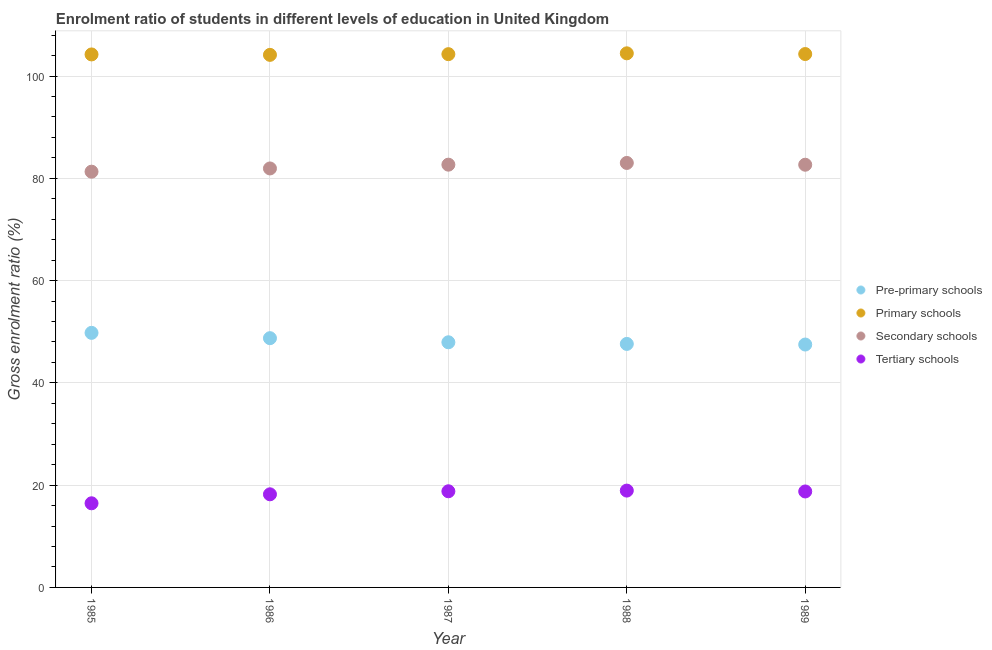How many different coloured dotlines are there?
Your answer should be compact. 4. What is the gross enrolment ratio in pre-primary schools in 1987?
Offer a very short reply. 47.93. Across all years, what is the maximum gross enrolment ratio in pre-primary schools?
Ensure brevity in your answer.  49.78. Across all years, what is the minimum gross enrolment ratio in primary schools?
Keep it short and to the point. 104.13. In which year was the gross enrolment ratio in secondary schools maximum?
Your answer should be compact. 1988. In which year was the gross enrolment ratio in primary schools minimum?
Make the answer very short. 1986. What is the total gross enrolment ratio in pre-primary schools in the graph?
Offer a very short reply. 241.56. What is the difference between the gross enrolment ratio in secondary schools in 1986 and that in 1988?
Make the answer very short. -1.08. What is the difference between the gross enrolment ratio in secondary schools in 1989 and the gross enrolment ratio in tertiary schools in 1988?
Ensure brevity in your answer.  63.72. What is the average gross enrolment ratio in tertiary schools per year?
Your response must be concise. 18.23. In the year 1986, what is the difference between the gross enrolment ratio in primary schools and gross enrolment ratio in tertiary schools?
Ensure brevity in your answer.  85.93. In how many years, is the gross enrolment ratio in tertiary schools greater than 88 %?
Provide a short and direct response. 0. What is the ratio of the gross enrolment ratio in tertiary schools in 1985 to that in 1986?
Offer a very short reply. 0.9. Is the gross enrolment ratio in pre-primary schools in 1985 less than that in 1986?
Offer a terse response. No. Is the difference between the gross enrolment ratio in tertiary schools in 1987 and 1988 greater than the difference between the gross enrolment ratio in pre-primary schools in 1987 and 1988?
Keep it short and to the point. No. What is the difference between the highest and the second highest gross enrolment ratio in secondary schools?
Offer a very short reply. 0.34. What is the difference between the highest and the lowest gross enrolment ratio in secondary schools?
Offer a very short reply. 1.71. In how many years, is the gross enrolment ratio in pre-primary schools greater than the average gross enrolment ratio in pre-primary schools taken over all years?
Ensure brevity in your answer.  2. Is it the case that in every year, the sum of the gross enrolment ratio in secondary schools and gross enrolment ratio in tertiary schools is greater than the sum of gross enrolment ratio in primary schools and gross enrolment ratio in pre-primary schools?
Your answer should be very brief. Yes. Does the gross enrolment ratio in tertiary schools monotonically increase over the years?
Your response must be concise. No. Is the gross enrolment ratio in pre-primary schools strictly less than the gross enrolment ratio in secondary schools over the years?
Keep it short and to the point. Yes. How many dotlines are there?
Offer a terse response. 4. How many years are there in the graph?
Give a very brief answer. 5. Are the values on the major ticks of Y-axis written in scientific E-notation?
Your answer should be compact. No. Does the graph contain grids?
Ensure brevity in your answer.  Yes. Where does the legend appear in the graph?
Make the answer very short. Center right. How many legend labels are there?
Keep it short and to the point. 4. How are the legend labels stacked?
Offer a terse response. Vertical. What is the title of the graph?
Your answer should be compact. Enrolment ratio of students in different levels of education in United Kingdom. What is the label or title of the Y-axis?
Offer a terse response. Gross enrolment ratio (%). What is the Gross enrolment ratio (%) of Pre-primary schools in 1985?
Provide a short and direct response. 49.78. What is the Gross enrolment ratio (%) of Primary schools in 1985?
Keep it short and to the point. 104.22. What is the Gross enrolment ratio (%) in Secondary schools in 1985?
Keep it short and to the point. 81.29. What is the Gross enrolment ratio (%) of Tertiary schools in 1985?
Your response must be concise. 16.45. What is the Gross enrolment ratio (%) in Pre-primary schools in 1986?
Keep it short and to the point. 48.74. What is the Gross enrolment ratio (%) of Primary schools in 1986?
Provide a succinct answer. 104.13. What is the Gross enrolment ratio (%) in Secondary schools in 1986?
Your answer should be very brief. 81.92. What is the Gross enrolment ratio (%) in Tertiary schools in 1986?
Provide a succinct answer. 18.21. What is the Gross enrolment ratio (%) in Pre-primary schools in 1987?
Give a very brief answer. 47.93. What is the Gross enrolment ratio (%) of Primary schools in 1987?
Provide a succinct answer. 104.27. What is the Gross enrolment ratio (%) of Secondary schools in 1987?
Ensure brevity in your answer.  82.66. What is the Gross enrolment ratio (%) in Tertiary schools in 1987?
Your response must be concise. 18.8. What is the Gross enrolment ratio (%) in Pre-primary schools in 1988?
Provide a succinct answer. 47.61. What is the Gross enrolment ratio (%) in Primary schools in 1988?
Provide a succinct answer. 104.44. What is the Gross enrolment ratio (%) in Secondary schools in 1988?
Your answer should be very brief. 83. What is the Gross enrolment ratio (%) in Tertiary schools in 1988?
Offer a terse response. 18.93. What is the Gross enrolment ratio (%) in Pre-primary schools in 1989?
Offer a very short reply. 47.49. What is the Gross enrolment ratio (%) of Primary schools in 1989?
Make the answer very short. 104.29. What is the Gross enrolment ratio (%) of Secondary schools in 1989?
Your answer should be very brief. 82.65. What is the Gross enrolment ratio (%) in Tertiary schools in 1989?
Provide a succinct answer. 18.76. Across all years, what is the maximum Gross enrolment ratio (%) of Pre-primary schools?
Your answer should be very brief. 49.78. Across all years, what is the maximum Gross enrolment ratio (%) of Primary schools?
Give a very brief answer. 104.44. Across all years, what is the maximum Gross enrolment ratio (%) in Secondary schools?
Provide a succinct answer. 83. Across all years, what is the maximum Gross enrolment ratio (%) in Tertiary schools?
Keep it short and to the point. 18.93. Across all years, what is the minimum Gross enrolment ratio (%) of Pre-primary schools?
Give a very brief answer. 47.49. Across all years, what is the minimum Gross enrolment ratio (%) in Primary schools?
Your answer should be very brief. 104.13. Across all years, what is the minimum Gross enrolment ratio (%) of Secondary schools?
Make the answer very short. 81.29. Across all years, what is the minimum Gross enrolment ratio (%) of Tertiary schools?
Offer a terse response. 16.45. What is the total Gross enrolment ratio (%) of Pre-primary schools in the graph?
Provide a short and direct response. 241.56. What is the total Gross enrolment ratio (%) in Primary schools in the graph?
Your answer should be very brief. 521.36. What is the total Gross enrolment ratio (%) of Secondary schools in the graph?
Your response must be concise. 411.53. What is the total Gross enrolment ratio (%) of Tertiary schools in the graph?
Offer a terse response. 91.16. What is the difference between the Gross enrolment ratio (%) of Pre-primary schools in 1985 and that in 1986?
Your response must be concise. 1.04. What is the difference between the Gross enrolment ratio (%) in Primary schools in 1985 and that in 1986?
Offer a terse response. 0.08. What is the difference between the Gross enrolment ratio (%) of Secondary schools in 1985 and that in 1986?
Your response must be concise. -0.63. What is the difference between the Gross enrolment ratio (%) in Tertiary schools in 1985 and that in 1986?
Your answer should be compact. -1.76. What is the difference between the Gross enrolment ratio (%) in Pre-primary schools in 1985 and that in 1987?
Keep it short and to the point. 1.84. What is the difference between the Gross enrolment ratio (%) of Primary schools in 1985 and that in 1987?
Keep it short and to the point. -0.05. What is the difference between the Gross enrolment ratio (%) of Secondary schools in 1985 and that in 1987?
Keep it short and to the point. -1.37. What is the difference between the Gross enrolment ratio (%) of Tertiary schools in 1985 and that in 1987?
Ensure brevity in your answer.  -2.35. What is the difference between the Gross enrolment ratio (%) of Pre-primary schools in 1985 and that in 1988?
Give a very brief answer. 2.16. What is the difference between the Gross enrolment ratio (%) of Primary schools in 1985 and that in 1988?
Make the answer very short. -0.22. What is the difference between the Gross enrolment ratio (%) in Secondary schools in 1985 and that in 1988?
Your response must be concise. -1.71. What is the difference between the Gross enrolment ratio (%) of Tertiary schools in 1985 and that in 1988?
Your response must be concise. -2.48. What is the difference between the Gross enrolment ratio (%) of Pre-primary schools in 1985 and that in 1989?
Provide a short and direct response. 2.28. What is the difference between the Gross enrolment ratio (%) of Primary schools in 1985 and that in 1989?
Offer a very short reply. -0.08. What is the difference between the Gross enrolment ratio (%) in Secondary schools in 1985 and that in 1989?
Offer a terse response. -1.36. What is the difference between the Gross enrolment ratio (%) in Tertiary schools in 1985 and that in 1989?
Offer a terse response. -2.31. What is the difference between the Gross enrolment ratio (%) in Pre-primary schools in 1986 and that in 1987?
Your response must be concise. 0.8. What is the difference between the Gross enrolment ratio (%) in Primary schools in 1986 and that in 1987?
Provide a succinct answer. -0.14. What is the difference between the Gross enrolment ratio (%) of Secondary schools in 1986 and that in 1987?
Your answer should be very brief. -0.74. What is the difference between the Gross enrolment ratio (%) of Tertiary schools in 1986 and that in 1987?
Ensure brevity in your answer.  -0.59. What is the difference between the Gross enrolment ratio (%) of Pre-primary schools in 1986 and that in 1988?
Give a very brief answer. 1.12. What is the difference between the Gross enrolment ratio (%) in Primary schools in 1986 and that in 1988?
Keep it short and to the point. -0.3. What is the difference between the Gross enrolment ratio (%) of Secondary schools in 1986 and that in 1988?
Provide a short and direct response. -1.08. What is the difference between the Gross enrolment ratio (%) in Tertiary schools in 1986 and that in 1988?
Provide a succinct answer. -0.73. What is the difference between the Gross enrolment ratio (%) in Pre-primary schools in 1986 and that in 1989?
Your answer should be compact. 1.24. What is the difference between the Gross enrolment ratio (%) in Primary schools in 1986 and that in 1989?
Your response must be concise. -0.16. What is the difference between the Gross enrolment ratio (%) of Secondary schools in 1986 and that in 1989?
Offer a very short reply. -0.73. What is the difference between the Gross enrolment ratio (%) in Tertiary schools in 1986 and that in 1989?
Offer a very short reply. -0.56. What is the difference between the Gross enrolment ratio (%) in Pre-primary schools in 1987 and that in 1988?
Offer a terse response. 0.32. What is the difference between the Gross enrolment ratio (%) in Primary schools in 1987 and that in 1988?
Ensure brevity in your answer.  -0.16. What is the difference between the Gross enrolment ratio (%) in Secondary schools in 1987 and that in 1988?
Offer a terse response. -0.34. What is the difference between the Gross enrolment ratio (%) in Tertiary schools in 1987 and that in 1988?
Your answer should be compact. -0.13. What is the difference between the Gross enrolment ratio (%) in Pre-primary schools in 1987 and that in 1989?
Make the answer very short. 0.44. What is the difference between the Gross enrolment ratio (%) in Primary schools in 1987 and that in 1989?
Offer a very short reply. -0.02. What is the difference between the Gross enrolment ratio (%) of Secondary schools in 1987 and that in 1989?
Your response must be concise. 0.01. What is the difference between the Gross enrolment ratio (%) of Tertiary schools in 1987 and that in 1989?
Give a very brief answer. 0.04. What is the difference between the Gross enrolment ratio (%) in Pre-primary schools in 1988 and that in 1989?
Give a very brief answer. 0.12. What is the difference between the Gross enrolment ratio (%) of Primary schools in 1988 and that in 1989?
Provide a short and direct response. 0.14. What is the difference between the Gross enrolment ratio (%) in Secondary schools in 1988 and that in 1989?
Your answer should be compact. 0.35. What is the difference between the Gross enrolment ratio (%) of Tertiary schools in 1988 and that in 1989?
Make the answer very short. 0.17. What is the difference between the Gross enrolment ratio (%) in Pre-primary schools in 1985 and the Gross enrolment ratio (%) in Primary schools in 1986?
Give a very brief answer. -54.36. What is the difference between the Gross enrolment ratio (%) in Pre-primary schools in 1985 and the Gross enrolment ratio (%) in Secondary schools in 1986?
Your response must be concise. -32.15. What is the difference between the Gross enrolment ratio (%) of Pre-primary schools in 1985 and the Gross enrolment ratio (%) of Tertiary schools in 1986?
Provide a succinct answer. 31.57. What is the difference between the Gross enrolment ratio (%) of Primary schools in 1985 and the Gross enrolment ratio (%) of Secondary schools in 1986?
Offer a very short reply. 22.29. What is the difference between the Gross enrolment ratio (%) of Primary schools in 1985 and the Gross enrolment ratio (%) of Tertiary schools in 1986?
Provide a succinct answer. 86.01. What is the difference between the Gross enrolment ratio (%) in Secondary schools in 1985 and the Gross enrolment ratio (%) in Tertiary schools in 1986?
Provide a short and direct response. 63.08. What is the difference between the Gross enrolment ratio (%) of Pre-primary schools in 1985 and the Gross enrolment ratio (%) of Primary schools in 1987?
Make the answer very short. -54.5. What is the difference between the Gross enrolment ratio (%) of Pre-primary schools in 1985 and the Gross enrolment ratio (%) of Secondary schools in 1987?
Keep it short and to the point. -32.89. What is the difference between the Gross enrolment ratio (%) of Pre-primary schools in 1985 and the Gross enrolment ratio (%) of Tertiary schools in 1987?
Keep it short and to the point. 30.97. What is the difference between the Gross enrolment ratio (%) of Primary schools in 1985 and the Gross enrolment ratio (%) of Secondary schools in 1987?
Give a very brief answer. 21.55. What is the difference between the Gross enrolment ratio (%) of Primary schools in 1985 and the Gross enrolment ratio (%) of Tertiary schools in 1987?
Offer a terse response. 85.42. What is the difference between the Gross enrolment ratio (%) in Secondary schools in 1985 and the Gross enrolment ratio (%) in Tertiary schools in 1987?
Keep it short and to the point. 62.49. What is the difference between the Gross enrolment ratio (%) of Pre-primary schools in 1985 and the Gross enrolment ratio (%) of Primary schools in 1988?
Your answer should be compact. -54.66. What is the difference between the Gross enrolment ratio (%) in Pre-primary schools in 1985 and the Gross enrolment ratio (%) in Secondary schools in 1988?
Give a very brief answer. -33.23. What is the difference between the Gross enrolment ratio (%) in Pre-primary schools in 1985 and the Gross enrolment ratio (%) in Tertiary schools in 1988?
Offer a very short reply. 30.84. What is the difference between the Gross enrolment ratio (%) in Primary schools in 1985 and the Gross enrolment ratio (%) in Secondary schools in 1988?
Provide a succinct answer. 21.22. What is the difference between the Gross enrolment ratio (%) in Primary schools in 1985 and the Gross enrolment ratio (%) in Tertiary schools in 1988?
Your answer should be compact. 85.28. What is the difference between the Gross enrolment ratio (%) in Secondary schools in 1985 and the Gross enrolment ratio (%) in Tertiary schools in 1988?
Ensure brevity in your answer.  62.36. What is the difference between the Gross enrolment ratio (%) of Pre-primary schools in 1985 and the Gross enrolment ratio (%) of Primary schools in 1989?
Give a very brief answer. -54.52. What is the difference between the Gross enrolment ratio (%) in Pre-primary schools in 1985 and the Gross enrolment ratio (%) in Secondary schools in 1989?
Your answer should be very brief. -32.88. What is the difference between the Gross enrolment ratio (%) in Pre-primary schools in 1985 and the Gross enrolment ratio (%) in Tertiary schools in 1989?
Provide a short and direct response. 31.01. What is the difference between the Gross enrolment ratio (%) of Primary schools in 1985 and the Gross enrolment ratio (%) of Secondary schools in 1989?
Your answer should be compact. 21.57. What is the difference between the Gross enrolment ratio (%) of Primary schools in 1985 and the Gross enrolment ratio (%) of Tertiary schools in 1989?
Give a very brief answer. 85.45. What is the difference between the Gross enrolment ratio (%) of Secondary schools in 1985 and the Gross enrolment ratio (%) of Tertiary schools in 1989?
Make the answer very short. 62.53. What is the difference between the Gross enrolment ratio (%) in Pre-primary schools in 1986 and the Gross enrolment ratio (%) in Primary schools in 1987?
Your answer should be very brief. -55.53. What is the difference between the Gross enrolment ratio (%) of Pre-primary schools in 1986 and the Gross enrolment ratio (%) of Secondary schools in 1987?
Provide a succinct answer. -33.93. What is the difference between the Gross enrolment ratio (%) in Pre-primary schools in 1986 and the Gross enrolment ratio (%) in Tertiary schools in 1987?
Ensure brevity in your answer.  29.94. What is the difference between the Gross enrolment ratio (%) of Primary schools in 1986 and the Gross enrolment ratio (%) of Secondary schools in 1987?
Provide a succinct answer. 21.47. What is the difference between the Gross enrolment ratio (%) of Primary schools in 1986 and the Gross enrolment ratio (%) of Tertiary schools in 1987?
Offer a terse response. 85.33. What is the difference between the Gross enrolment ratio (%) in Secondary schools in 1986 and the Gross enrolment ratio (%) in Tertiary schools in 1987?
Provide a short and direct response. 63.12. What is the difference between the Gross enrolment ratio (%) in Pre-primary schools in 1986 and the Gross enrolment ratio (%) in Primary schools in 1988?
Make the answer very short. -55.7. What is the difference between the Gross enrolment ratio (%) of Pre-primary schools in 1986 and the Gross enrolment ratio (%) of Secondary schools in 1988?
Make the answer very short. -34.26. What is the difference between the Gross enrolment ratio (%) of Pre-primary schools in 1986 and the Gross enrolment ratio (%) of Tertiary schools in 1988?
Your answer should be compact. 29.8. What is the difference between the Gross enrolment ratio (%) in Primary schools in 1986 and the Gross enrolment ratio (%) in Secondary schools in 1988?
Provide a short and direct response. 21.13. What is the difference between the Gross enrolment ratio (%) of Primary schools in 1986 and the Gross enrolment ratio (%) of Tertiary schools in 1988?
Ensure brevity in your answer.  85.2. What is the difference between the Gross enrolment ratio (%) of Secondary schools in 1986 and the Gross enrolment ratio (%) of Tertiary schools in 1988?
Your answer should be very brief. 62.99. What is the difference between the Gross enrolment ratio (%) of Pre-primary schools in 1986 and the Gross enrolment ratio (%) of Primary schools in 1989?
Offer a terse response. -55.56. What is the difference between the Gross enrolment ratio (%) in Pre-primary schools in 1986 and the Gross enrolment ratio (%) in Secondary schools in 1989?
Provide a short and direct response. -33.91. What is the difference between the Gross enrolment ratio (%) of Pre-primary schools in 1986 and the Gross enrolment ratio (%) of Tertiary schools in 1989?
Offer a terse response. 29.97. What is the difference between the Gross enrolment ratio (%) of Primary schools in 1986 and the Gross enrolment ratio (%) of Secondary schools in 1989?
Your answer should be compact. 21.48. What is the difference between the Gross enrolment ratio (%) of Primary schools in 1986 and the Gross enrolment ratio (%) of Tertiary schools in 1989?
Your answer should be compact. 85.37. What is the difference between the Gross enrolment ratio (%) of Secondary schools in 1986 and the Gross enrolment ratio (%) of Tertiary schools in 1989?
Your answer should be compact. 63.16. What is the difference between the Gross enrolment ratio (%) in Pre-primary schools in 1987 and the Gross enrolment ratio (%) in Primary schools in 1988?
Your response must be concise. -56.5. What is the difference between the Gross enrolment ratio (%) in Pre-primary schools in 1987 and the Gross enrolment ratio (%) in Secondary schools in 1988?
Give a very brief answer. -35.07. What is the difference between the Gross enrolment ratio (%) of Pre-primary schools in 1987 and the Gross enrolment ratio (%) of Tertiary schools in 1988?
Provide a short and direct response. 29. What is the difference between the Gross enrolment ratio (%) in Primary schools in 1987 and the Gross enrolment ratio (%) in Secondary schools in 1988?
Provide a short and direct response. 21.27. What is the difference between the Gross enrolment ratio (%) in Primary schools in 1987 and the Gross enrolment ratio (%) in Tertiary schools in 1988?
Make the answer very short. 85.34. What is the difference between the Gross enrolment ratio (%) in Secondary schools in 1987 and the Gross enrolment ratio (%) in Tertiary schools in 1988?
Offer a terse response. 63.73. What is the difference between the Gross enrolment ratio (%) in Pre-primary schools in 1987 and the Gross enrolment ratio (%) in Primary schools in 1989?
Offer a terse response. -56.36. What is the difference between the Gross enrolment ratio (%) in Pre-primary schools in 1987 and the Gross enrolment ratio (%) in Secondary schools in 1989?
Your answer should be compact. -34.72. What is the difference between the Gross enrolment ratio (%) in Pre-primary schools in 1987 and the Gross enrolment ratio (%) in Tertiary schools in 1989?
Keep it short and to the point. 29.17. What is the difference between the Gross enrolment ratio (%) of Primary schools in 1987 and the Gross enrolment ratio (%) of Secondary schools in 1989?
Your response must be concise. 21.62. What is the difference between the Gross enrolment ratio (%) of Primary schools in 1987 and the Gross enrolment ratio (%) of Tertiary schools in 1989?
Give a very brief answer. 85.51. What is the difference between the Gross enrolment ratio (%) in Secondary schools in 1987 and the Gross enrolment ratio (%) in Tertiary schools in 1989?
Provide a short and direct response. 63.9. What is the difference between the Gross enrolment ratio (%) in Pre-primary schools in 1988 and the Gross enrolment ratio (%) in Primary schools in 1989?
Offer a very short reply. -56.68. What is the difference between the Gross enrolment ratio (%) of Pre-primary schools in 1988 and the Gross enrolment ratio (%) of Secondary schools in 1989?
Make the answer very short. -35.04. What is the difference between the Gross enrolment ratio (%) of Pre-primary schools in 1988 and the Gross enrolment ratio (%) of Tertiary schools in 1989?
Offer a very short reply. 28.85. What is the difference between the Gross enrolment ratio (%) in Primary schools in 1988 and the Gross enrolment ratio (%) in Secondary schools in 1989?
Give a very brief answer. 21.78. What is the difference between the Gross enrolment ratio (%) in Primary schools in 1988 and the Gross enrolment ratio (%) in Tertiary schools in 1989?
Offer a very short reply. 85.67. What is the difference between the Gross enrolment ratio (%) in Secondary schools in 1988 and the Gross enrolment ratio (%) in Tertiary schools in 1989?
Provide a short and direct response. 64.24. What is the average Gross enrolment ratio (%) in Pre-primary schools per year?
Provide a short and direct response. 48.31. What is the average Gross enrolment ratio (%) in Primary schools per year?
Your response must be concise. 104.27. What is the average Gross enrolment ratio (%) of Secondary schools per year?
Provide a succinct answer. 82.31. What is the average Gross enrolment ratio (%) of Tertiary schools per year?
Make the answer very short. 18.23. In the year 1985, what is the difference between the Gross enrolment ratio (%) in Pre-primary schools and Gross enrolment ratio (%) in Primary schools?
Offer a very short reply. -54.44. In the year 1985, what is the difference between the Gross enrolment ratio (%) in Pre-primary schools and Gross enrolment ratio (%) in Secondary schools?
Your answer should be compact. -31.52. In the year 1985, what is the difference between the Gross enrolment ratio (%) of Pre-primary schools and Gross enrolment ratio (%) of Tertiary schools?
Your response must be concise. 33.32. In the year 1985, what is the difference between the Gross enrolment ratio (%) in Primary schools and Gross enrolment ratio (%) in Secondary schools?
Give a very brief answer. 22.93. In the year 1985, what is the difference between the Gross enrolment ratio (%) in Primary schools and Gross enrolment ratio (%) in Tertiary schools?
Offer a terse response. 87.77. In the year 1985, what is the difference between the Gross enrolment ratio (%) of Secondary schools and Gross enrolment ratio (%) of Tertiary schools?
Provide a short and direct response. 64.84. In the year 1986, what is the difference between the Gross enrolment ratio (%) of Pre-primary schools and Gross enrolment ratio (%) of Primary schools?
Your response must be concise. -55.4. In the year 1986, what is the difference between the Gross enrolment ratio (%) of Pre-primary schools and Gross enrolment ratio (%) of Secondary schools?
Keep it short and to the point. -33.19. In the year 1986, what is the difference between the Gross enrolment ratio (%) of Pre-primary schools and Gross enrolment ratio (%) of Tertiary schools?
Your response must be concise. 30.53. In the year 1986, what is the difference between the Gross enrolment ratio (%) in Primary schools and Gross enrolment ratio (%) in Secondary schools?
Keep it short and to the point. 22.21. In the year 1986, what is the difference between the Gross enrolment ratio (%) in Primary schools and Gross enrolment ratio (%) in Tertiary schools?
Make the answer very short. 85.93. In the year 1986, what is the difference between the Gross enrolment ratio (%) in Secondary schools and Gross enrolment ratio (%) in Tertiary schools?
Your answer should be compact. 63.72. In the year 1987, what is the difference between the Gross enrolment ratio (%) of Pre-primary schools and Gross enrolment ratio (%) of Primary schools?
Keep it short and to the point. -56.34. In the year 1987, what is the difference between the Gross enrolment ratio (%) in Pre-primary schools and Gross enrolment ratio (%) in Secondary schools?
Offer a terse response. -34.73. In the year 1987, what is the difference between the Gross enrolment ratio (%) of Pre-primary schools and Gross enrolment ratio (%) of Tertiary schools?
Your response must be concise. 29.13. In the year 1987, what is the difference between the Gross enrolment ratio (%) of Primary schools and Gross enrolment ratio (%) of Secondary schools?
Your response must be concise. 21.61. In the year 1987, what is the difference between the Gross enrolment ratio (%) of Primary schools and Gross enrolment ratio (%) of Tertiary schools?
Offer a terse response. 85.47. In the year 1987, what is the difference between the Gross enrolment ratio (%) of Secondary schools and Gross enrolment ratio (%) of Tertiary schools?
Provide a short and direct response. 63.86. In the year 1988, what is the difference between the Gross enrolment ratio (%) in Pre-primary schools and Gross enrolment ratio (%) in Primary schools?
Your response must be concise. -56.82. In the year 1988, what is the difference between the Gross enrolment ratio (%) of Pre-primary schools and Gross enrolment ratio (%) of Secondary schools?
Offer a terse response. -35.39. In the year 1988, what is the difference between the Gross enrolment ratio (%) in Pre-primary schools and Gross enrolment ratio (%) in Tertiary schools?
Ensure brevity in your answer.  28.68. In the year 1988, what is the difference between the Gross enrolment ratio (%) in Primary schools and Gross enrolment ratio (%) in Secondary schools?
Make the answer very short. 21.43. In the year 1988, what is the difference between the Gross enrolment ratio (%) of Primary schools and Gross enrolment ratio (%) of Tertiary schools?
Offer a very short reply. 85.5. In the year 1988, what is the difference between the Gross enrolment ratio (%) in Secondary schools and Gross enrolment ratio (%) in Tertiary schools?
Your answer should be compact. 64.07. In the year 1989, what is the difference between the Gross enrolment ratio (%) of Pre-primary schools and Gross enrolment ratio (%) of Primary schools?
Your response must be concise. -56.8. In the year 1989, what is the difference between the Gross enrolment ratio (%) of Pre-primary schools and Gross enrolment ratio (%) of Secondary schools?
Your answer should be very brief. -35.16. In the year 1989, what is the difference between the Gross enrolment ratio (%) of Pre-primary schools and Gross enrolment ratio (%) of Tertiary schools?
Provide a succinct answer. 28.73. In the year 1989, what is the difference between the Gross enrolment ratio (%) in Primary schools and Gross enrolment ratio (%) in Secondary schools?
Keep it short and to the point. 21.64. In the year 1989, what is the difference between the Gross enrolment ratio (%) in Primary schools and Gross enrolment ratio (%) in Tertiary schools?
Give a very brief answer. 85.53. In the year 1989, what is the difference between the Gross enrolment ratio (%) in Secondary schools and Gross enrolment ratio (%) in Tertiary schools?
Provide a short and direct response. 63.89. What is the ratio of the Gross enrolment ratio (%) of Pre-primary schools in 1985 to that in 1986?
Provide a short and direct response. 1.02. What is the ratio of the Gross enrolment ratio (%) in Primary schools in 1985 to that in 1986?
Your answer should be very brief. 1. What is the ratio of the Gross enrolment ratio (%) of Secondary schools in 1985 to that in 1986?
Provide a succinct answer. 0.99. What is the ratio of the Gross enrolment ratio (%) of Tertiary schools in 1985 to that in 1986?
Make the answer very short. 0.9. What is the ratio of the Gross enrolment ratio (%) of Pre-primary schools in 1985 to that in 1987?
Make the answer very short. 1.04. What is the ratio of the Gross enrolment ratio (%) of Secondary schools in 1985 to that in 1987?
Your response must be concise. 0.98. What is the ratio of the Gross enrolment ratio (%) in Tertiary schools in 1985 to that in 1987?
Offer a terse response. 0.88. What is the ratio of the Gross enrolment ratio (%) in Pre-primary schools in 1985 to that in 1988?
Provide a succinct answer. 1.05. What is the ratio of the Gross enrolment ratio (%) in Secondary schools in 1985 to that in 1988?
Provide a succinct answer. 0.98. What is the ratio of the Gross enrolment ratio (%) of Tertiary schools in 1985 to that in 1988?
Ensure brevity in your answer.  0.87. What is the ratio of the Gross enrolment ratio (%) in Pre-primary schools in 1985 to that in 1989?
Your response must be concise. 1.05. What is the ratio of the Gross enrolment ratio (%) in Secondary schools in 1985 to that in 1989?
Your response must be concise. 0.98. What is the ratio of the Gross enrolment ratio (%) of Tertiary schools in 1985 to that in 1989?
Keep it short and to the point. 0.88. What is the ratio of the Gross enrolment ratio (%) of Pre-primary schools in 1986 to that in 1987?
Make the answer very short. 1.02. What is the ratio of the Gross enrolment ratio (%) of Primary schools in 1986 to that in 1987?
Give a very brief answer. 1. What is the ratio of the Gross enrolment ratio (%) in Secondary schools in 1986 to that in 1987?
Your response must be concise. 0.99. What is the ratio of the Gross enrolment ratio (%) of Tertiary schools in 1986 to that in 1987?
Your answer should be very brief. 0.97. What is the ratio of the Gross enrolment ratio (%) of Pre-primary schools in 1986 to that in 1988?
Offer a very short reply. 1.02. What is the ratio of the Gross enrolment ratio (%) of Primary schools in 1986 to that in 1988?
Give a very brief answer. 1. What is the ratio of the Gross enrolment ratio (%) in Secondary schools in 1986 to that in 1988?
Provide a short and direct response. 0.99. What is the ratio of the Gross enrolment ratio (%) of Tertiary schools in 1986 to that in 1988?
Offer a very short reply. 0.96. What is the ratio of the Gross enrolment ratio (%) in Pre-primary schools in 1986 to that in 1989?
Ensure brevity in your answer.  1.03. What is the ratio of the Gross enrolment ratio (%) in Primary schools in 1986 to that in 1989?
Your response must be concise. 1. What is the ratio of the Gross enrolment ratio (%) of Tertiary schools in 1986 to that in 1989?
Your answer should be compact. 0.97. What is the ratio of the Gross enrolment ratio (%) in Secondary schools in 1987 to that in 1988?
Provide a short and direct response. 1. What is the ratio of the Gross enrolment ratio (%) in Pre-primary schools in 1987 to that in 1989?
Your answer should be compact. 1.01. What is the ratio of the Gross enrolment ratio (%) of Tertiary schools in 1987 to that in 1989?
Ensure brevity in your answer.  1. What is the ratio of the Gross enrolment ratio (%) in Pre-primary schools in 1988 to that in 1989?
Ensure brevity in your answer.  1. What is the ratio of the Gross enrolment ratio (%) of Secondary schools in 1988 to that in 1989?
Offer a terse response. 1. What is the ratio of the Gross enrolment ratio (%) of Tertiary schools in 1988 to that in 1989?
Offer a very short reply. 1.01. What is the difference between the highest and the second highest Gross enrolment ratio (%) of Pre-primary schools?
Ensure brevity in your answer.  1.04. What is the difference between the highest and the second highest Gross enrolment ratio (%) in Primary schools?
Keep it short and to the point. 0.14. What is the difference between the highest and the second highest Gross enrolment ratio (%) in Secondary schools?
Your answer should be compact. 0.34. What is the difference between the highest and the second highest Gross enrolment ratio (%) in Tertiary schools?
Ensure brevity in your answer.  0.13. What is the difference between the highest and the lowest Gross enrolment ratio (%) in Pre-primary schools?
Keep it short and to the point. 2.28. What is the difference between the highest and the lowest Gross enrolment ratio (%) of Primary schools?
Offer a terse response. 0.3. What is the difference between the highest and the lowest Gross enrolment ratio (%) of Secondary schools?
Provide a short and direct response. 1.71. What is the difference between the highest and the lowest Gross enrolment ratio (%) in Tertiary schools?
Your response must be concise. 2.48. 